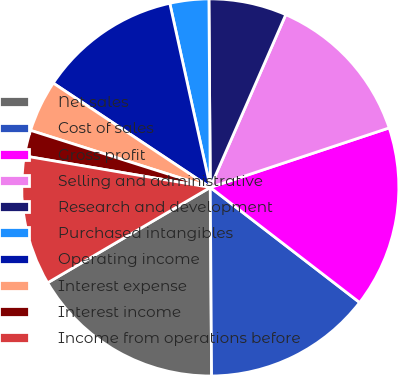<chart> <loc_0><loc_0><loc_500><loc_500><pie_chart><fcel>Net sales<fcel>Cost of sales<fcel>Gross profit<fcel>Selling and administrative<fcel>Research and development<fcel>Purchased intangibles<fcel>Operating income<fcel>Interest expense<fcel>Interest income<fcel>Income from operations before<nl><fcel>16.67%<fcel>14.44%<fcel>15.56%<fcel>13.33%<fcel>6.67%<fcel>3.33%<fcel>12.22%<fcel>4.44%<fcel>2.22%<fcel>11.11%<nl></chart> 